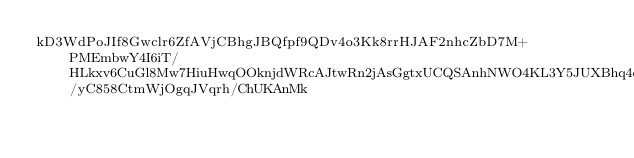Convert code to text. <code><loc_0><loc_0><loc_500><loc_500><_SML_>kD3WdPoJIf8Gwclr6ZfAVjCBhgJBQfpf9QDv4o3Kk8rrHJAF2nhcZbD7M+PMEmbwY4I6iT/HLkxv6CuGl8Mw7HiuHwqOOknjdWRcAJtwRn2jAsGgtxUCQSAnhNWO4KL3Y5JUXBhq4qXZwwqfDZqIuPXH5tUlMSSxaNn4ggsU4meXAMTn/yC858CtmWjOgqJVqrh/ChUKAnMk</code> 